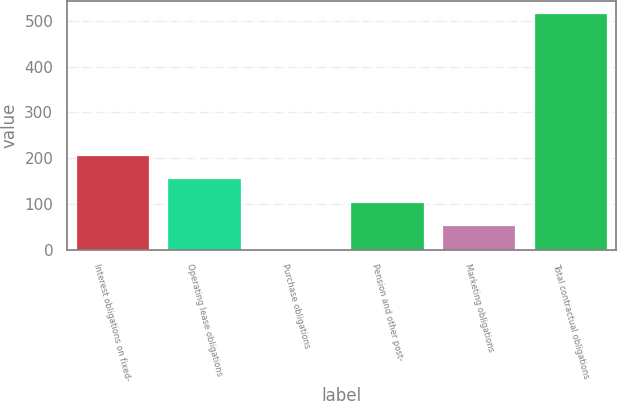<chart> <loc_0><loc_0><loc_500><loc_500><bar_chart><fcel>Interest obligations on fixed-<fcel>Operating lease obligations<fcel>Purchase obligations<fcel>Pension and other post-<fcel>Marketing obligations<fcel>Total contractual obligations<nl><fcel>207.74<fcel>156.23<fcel>1.7<fcel>104.72<fcel>53.21<fcel>516.8<nl></chart> 